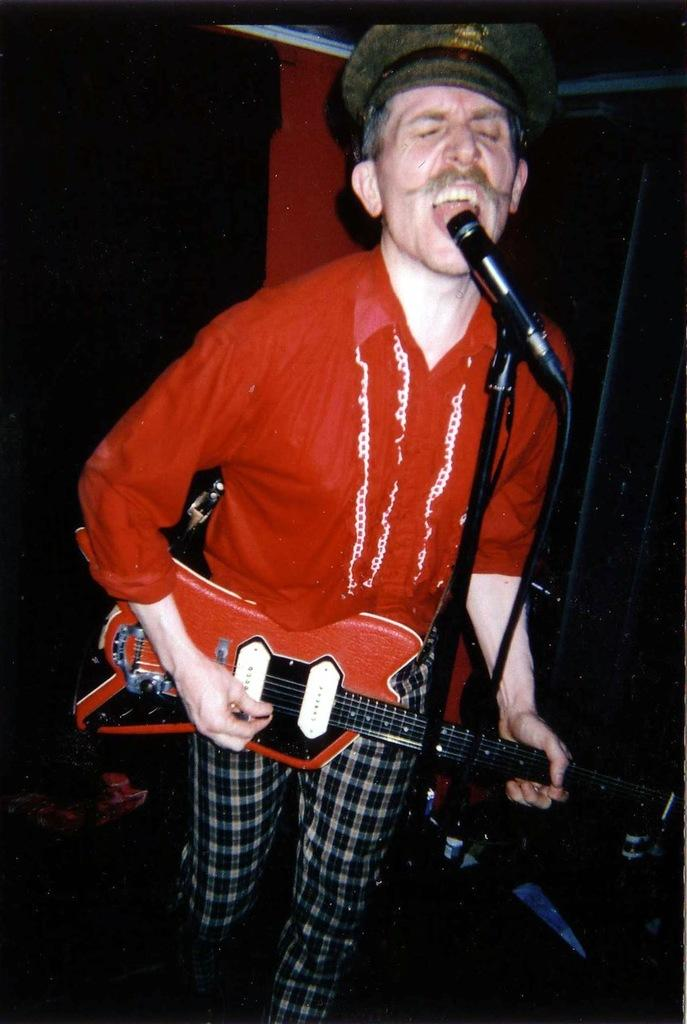What is the man in the image doing? The man is holding a guitar and singing. What object is in front of the man? There is a microphone in front of the man. What is the microphone attached to in the image? The microphone is attached to a microphone stand in the image. What type of pen is the man using to write lyrics in the image? There is no pen visible in the image, and the man is singing, not writing lyrics. Is there any water visible in the image? No, there is no water present in the image. 